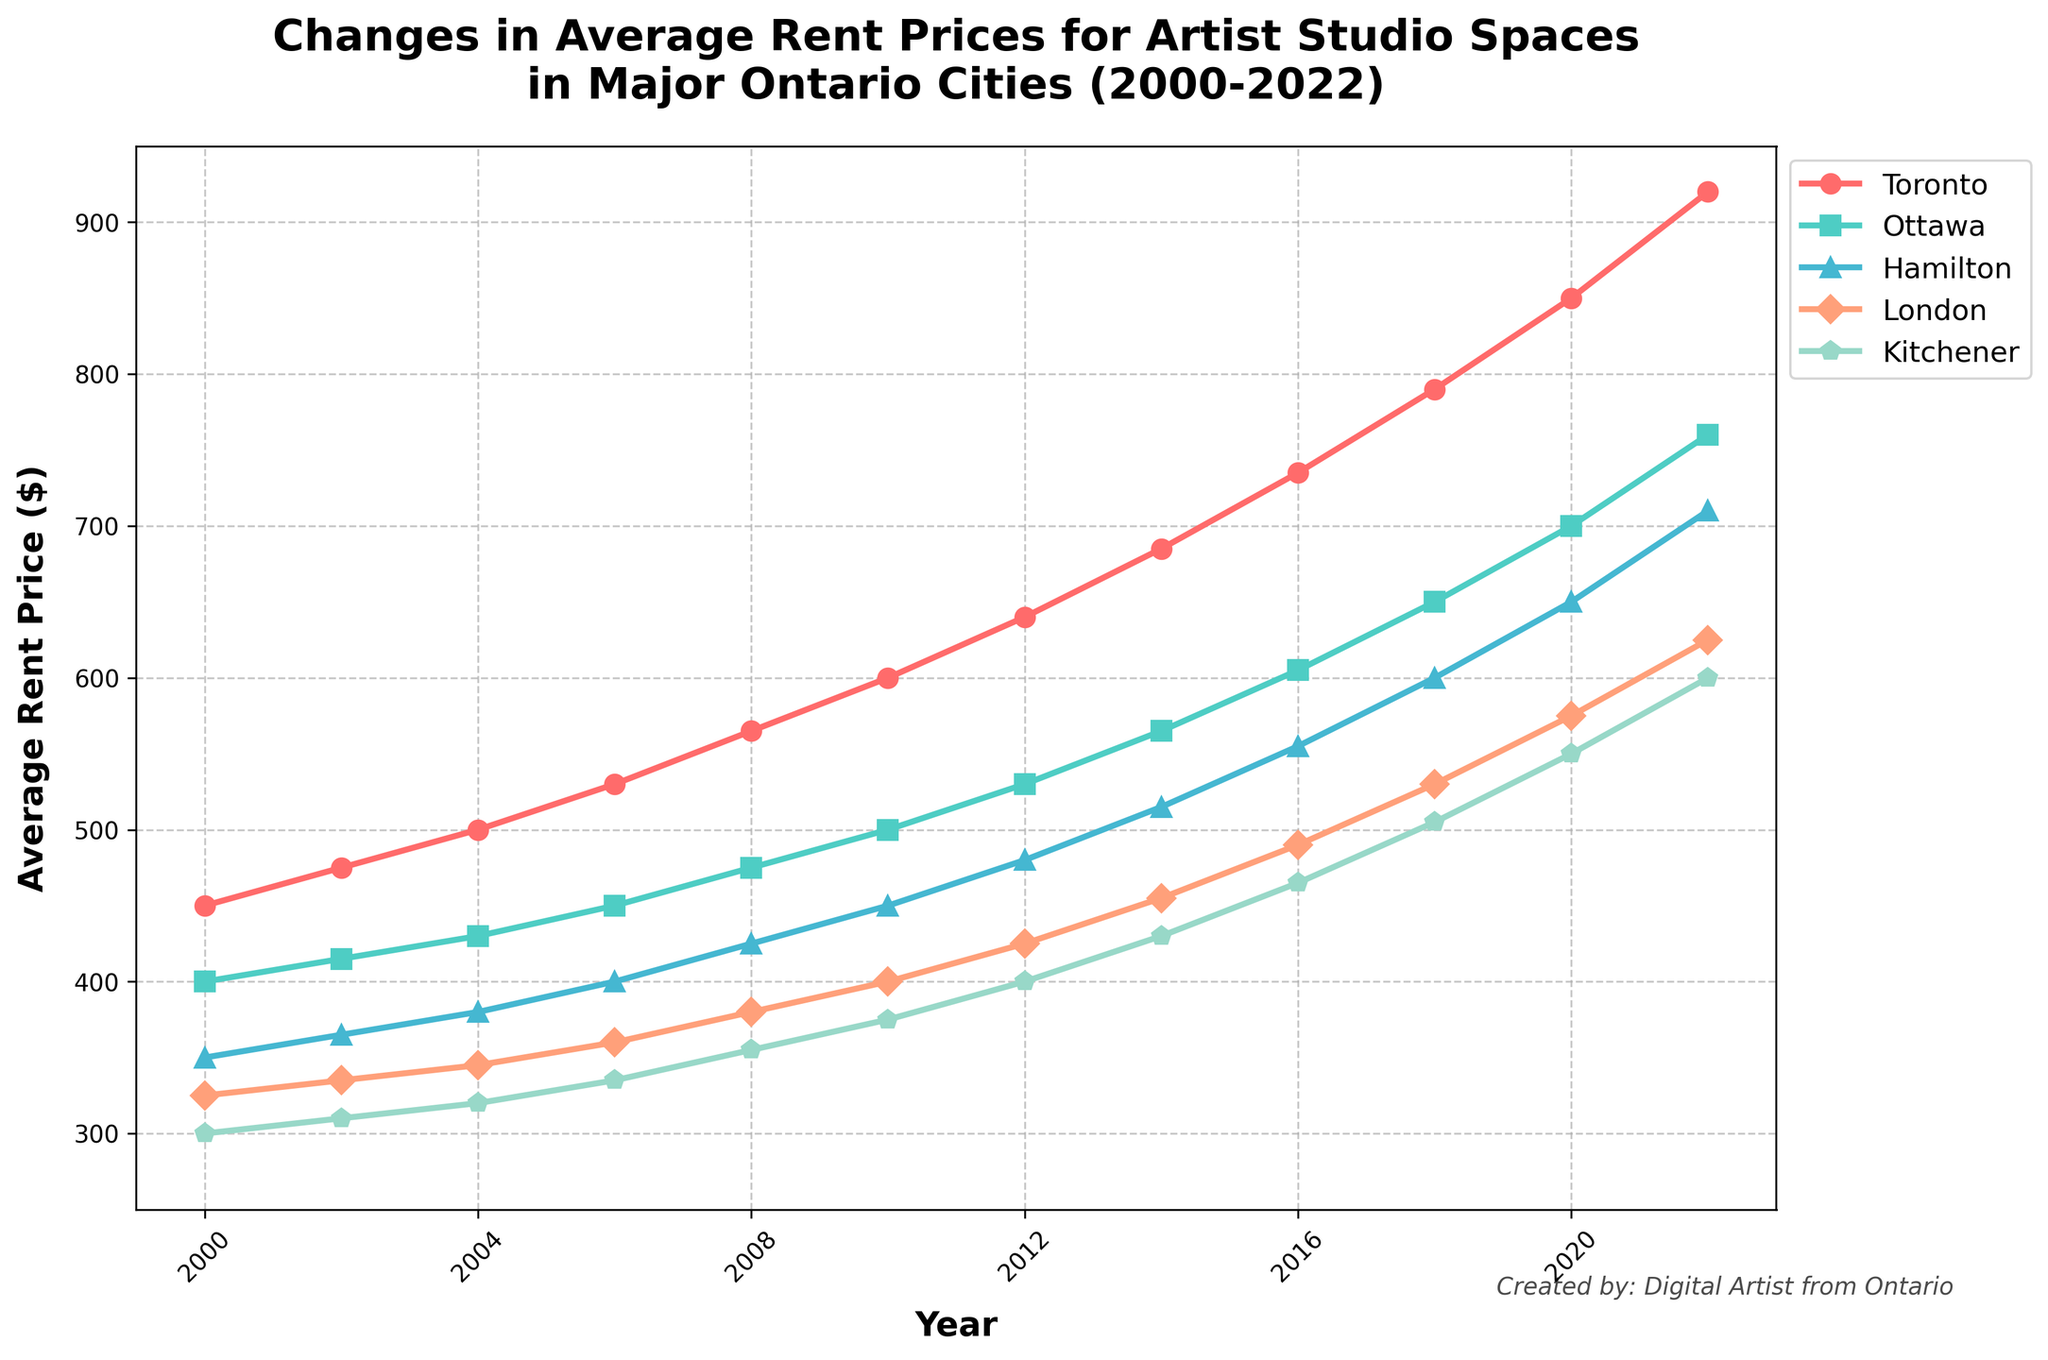How has the average rent price for artist studio spaces in London changed from 2000 to 2022? To find this, check the y-axis values for London in 2000 and 2022: in 2000, it is $325 and in 2022, it is $625. The difference is $625 - $325 = $300.
Answer: $300 Which city had the highest average rent price for artist studio spaces in 2022? To determine this, look at the endpoints of each line (2022) and find the highest y-axis value. Toronto has the highest value at $920.
Answer: Toronto Between 2010 and 2020, which city saw the greatest increase in average rent prices for artist studio spaces? First, check the y-axis values for all cities in 2010 and 2020. Then, calculate the differences for each city: Toronto ($250), Ottawa ($200), Hamilton ($200), London ($175), and Kitchener ($175). Toronto has the greatest increase.
Answer: Toronto What is the average rent price for artist studio spaces across all cities in 2006? To get the average, add the y-axis values of all cities in 2006: 530 (Toronto) + 450 (Ottawa) + 400 (Hamilton) + 360 (London) + 335 (Kitchener) = 2075. Divide this sum by the number of cities (5) to get 2075/5 = $415.
Answer: $415 Did any city experience a decline in average rent price between any two consecutive years? Examine the slope of each city's line between consecutive data points. None of the lines have a negative slope, indicating no city experienced a decline in any year.
Answer: No How does the increase in rent price for artist studio spaces in Hamilton from 2000 to 2022 compare to Ottawa's increase over the same period? Calculate the increase for Hamilton: $710 - $350 = $360. Calculate the increase for Ottawa: $760 - $400 = $360. Both cities have the same increase.
Answer: Same Which year had the most significant overall rise in average rent prices for artist studio spaces across all cities? Calculate the yearly increase for each city and add them for all years. The year with the highest total increase will be the answer. From the data, the significant overall rise is from 2018 to 2020: Toronto ($60), Ottawa ($50), Hamilton ($50), London ($45), Kitchener ($45) totaling $250.
Answer: 2018-2020 Which city had the smallest increase in rent prices for artist studio spaces from 2000 to 2008? Calculate the increase for each city between 2000 and 2008: Toronto ($115), Ottawa ($75), Hamilton ($75), London ($55), Kitchener ($55). Kitchener and London have the smallest increase at $55.
Answer: Kitchener, London 